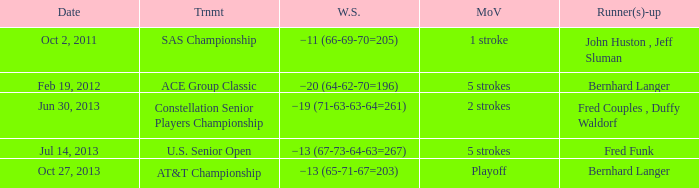When was there a 5-stroke victory margin with a -13 (67-73-64-63=267) winning score? Jul 14, 2013. 